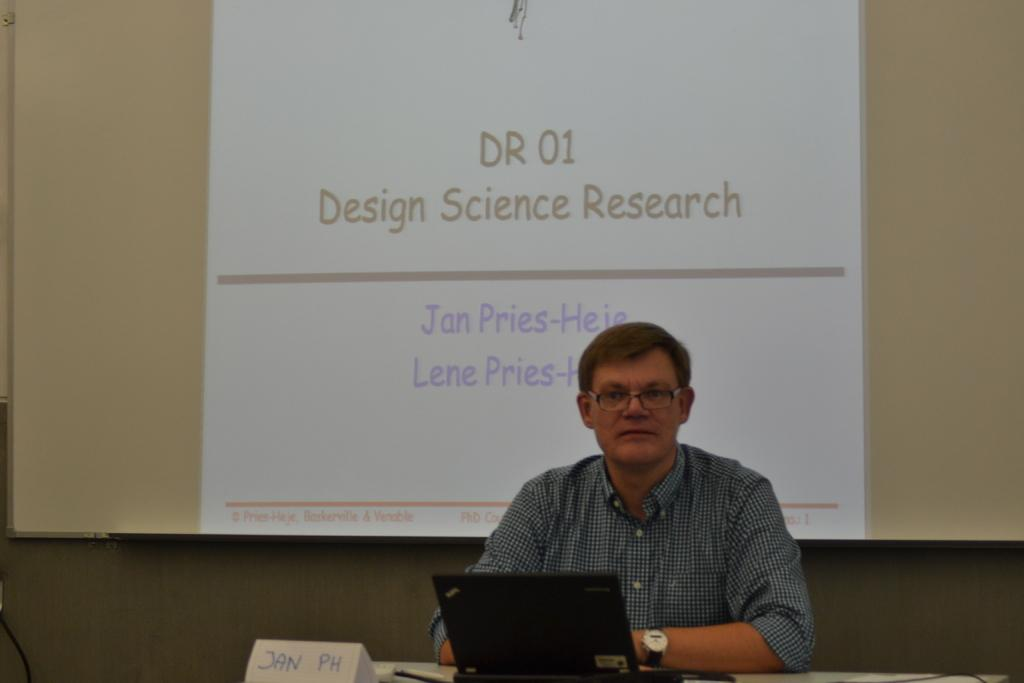What is the man in the image doing? The man is sitting in the image. Where is the man sitting in relation to the table? The man is sitting in front of a table. What is on the table in the image? There is a laptop on the table. What is being projected onto the board behind the man? A projector is being projected onto the board. What word is being spelled out by the cup on the table? There is no cup present in the image, and therefore no word can be spelled out by it. 